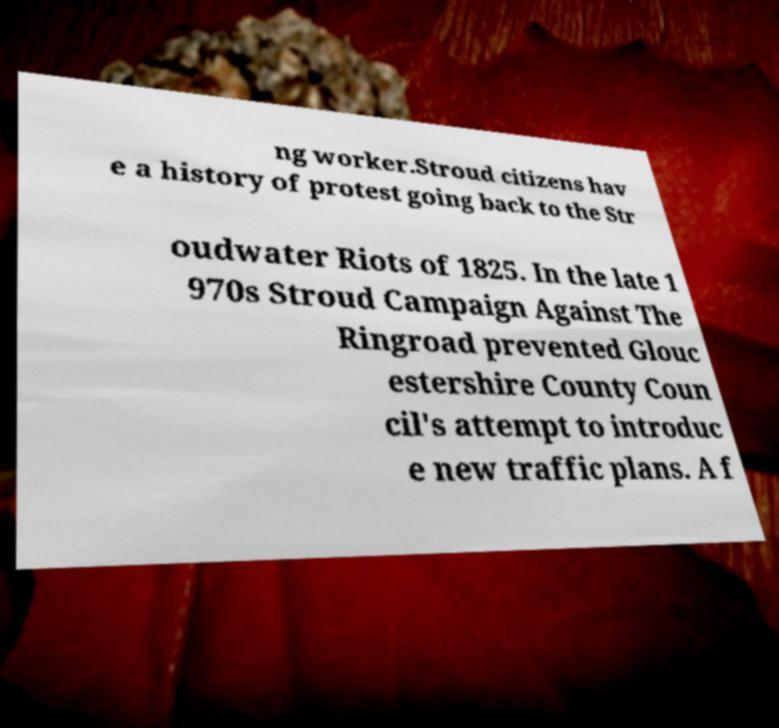There's text embedded in this image that I need extracted. Can you transcribe it verbatim? ng worker.Stroud citizens hav e a history of protest going back to the Str oudwater Riots of 1825. In the late 1 970s Stroud Campaign Against The Ringroad prevented Glouc estershire County Coun cil's attempt to introduc e new traffic plans. A f 